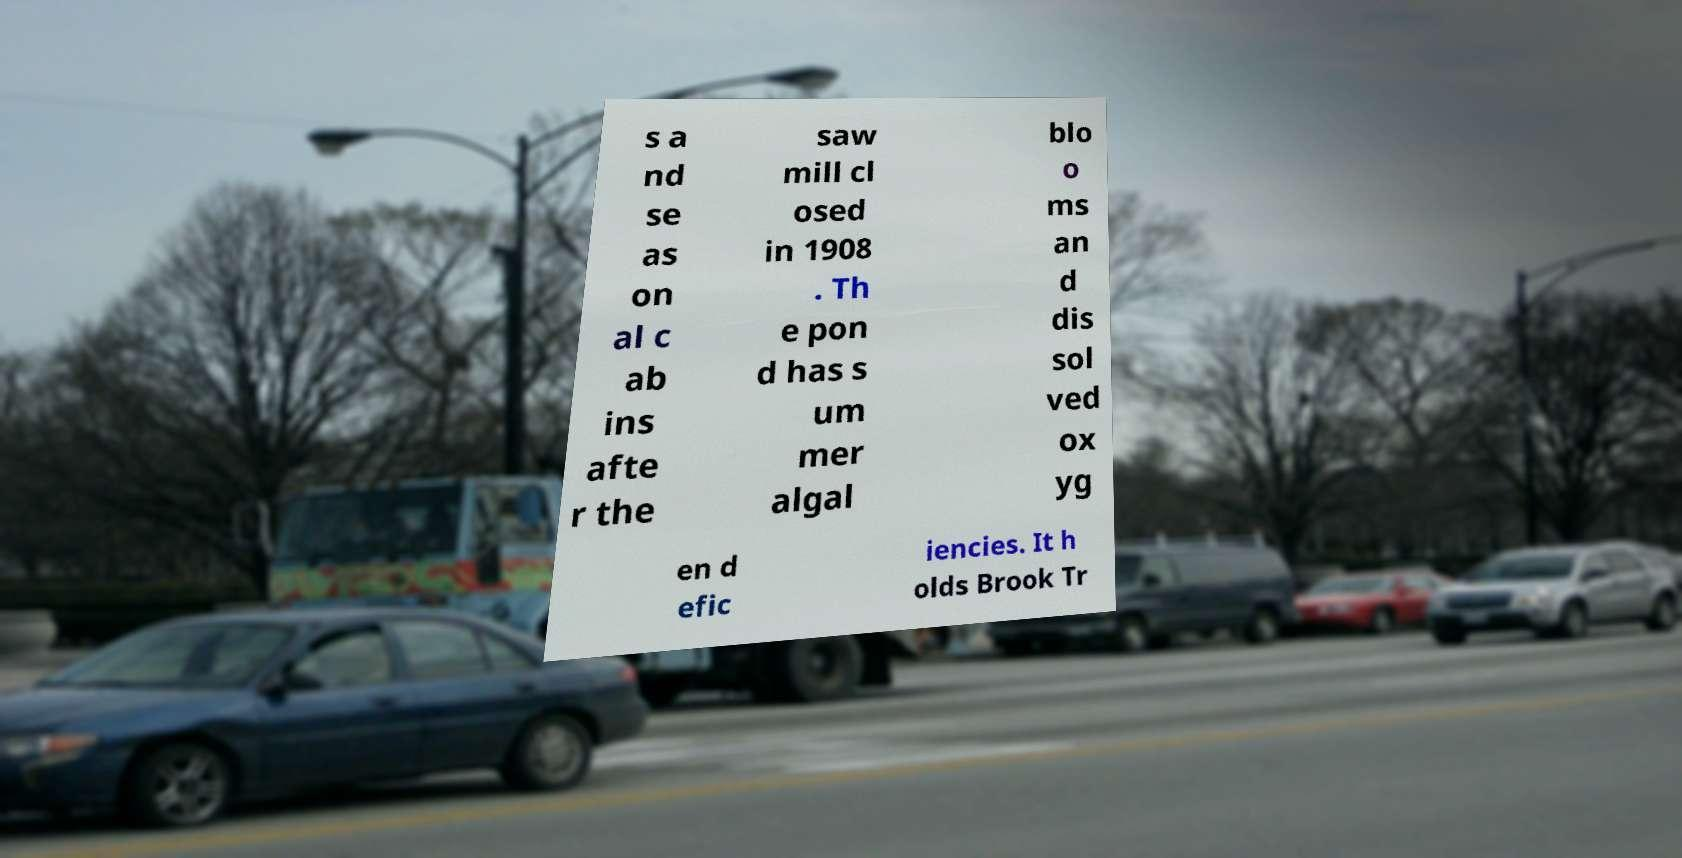Could you assist in decoding the text presented in this image and type it out clearly? s a nd se as on al c ab ins afte r the saw mill cl osed in 1908 . Th e pon d has s um mer algal blo o ms an d dis sol ved ox yg en d efic iencies. It h olds Brook Tr 